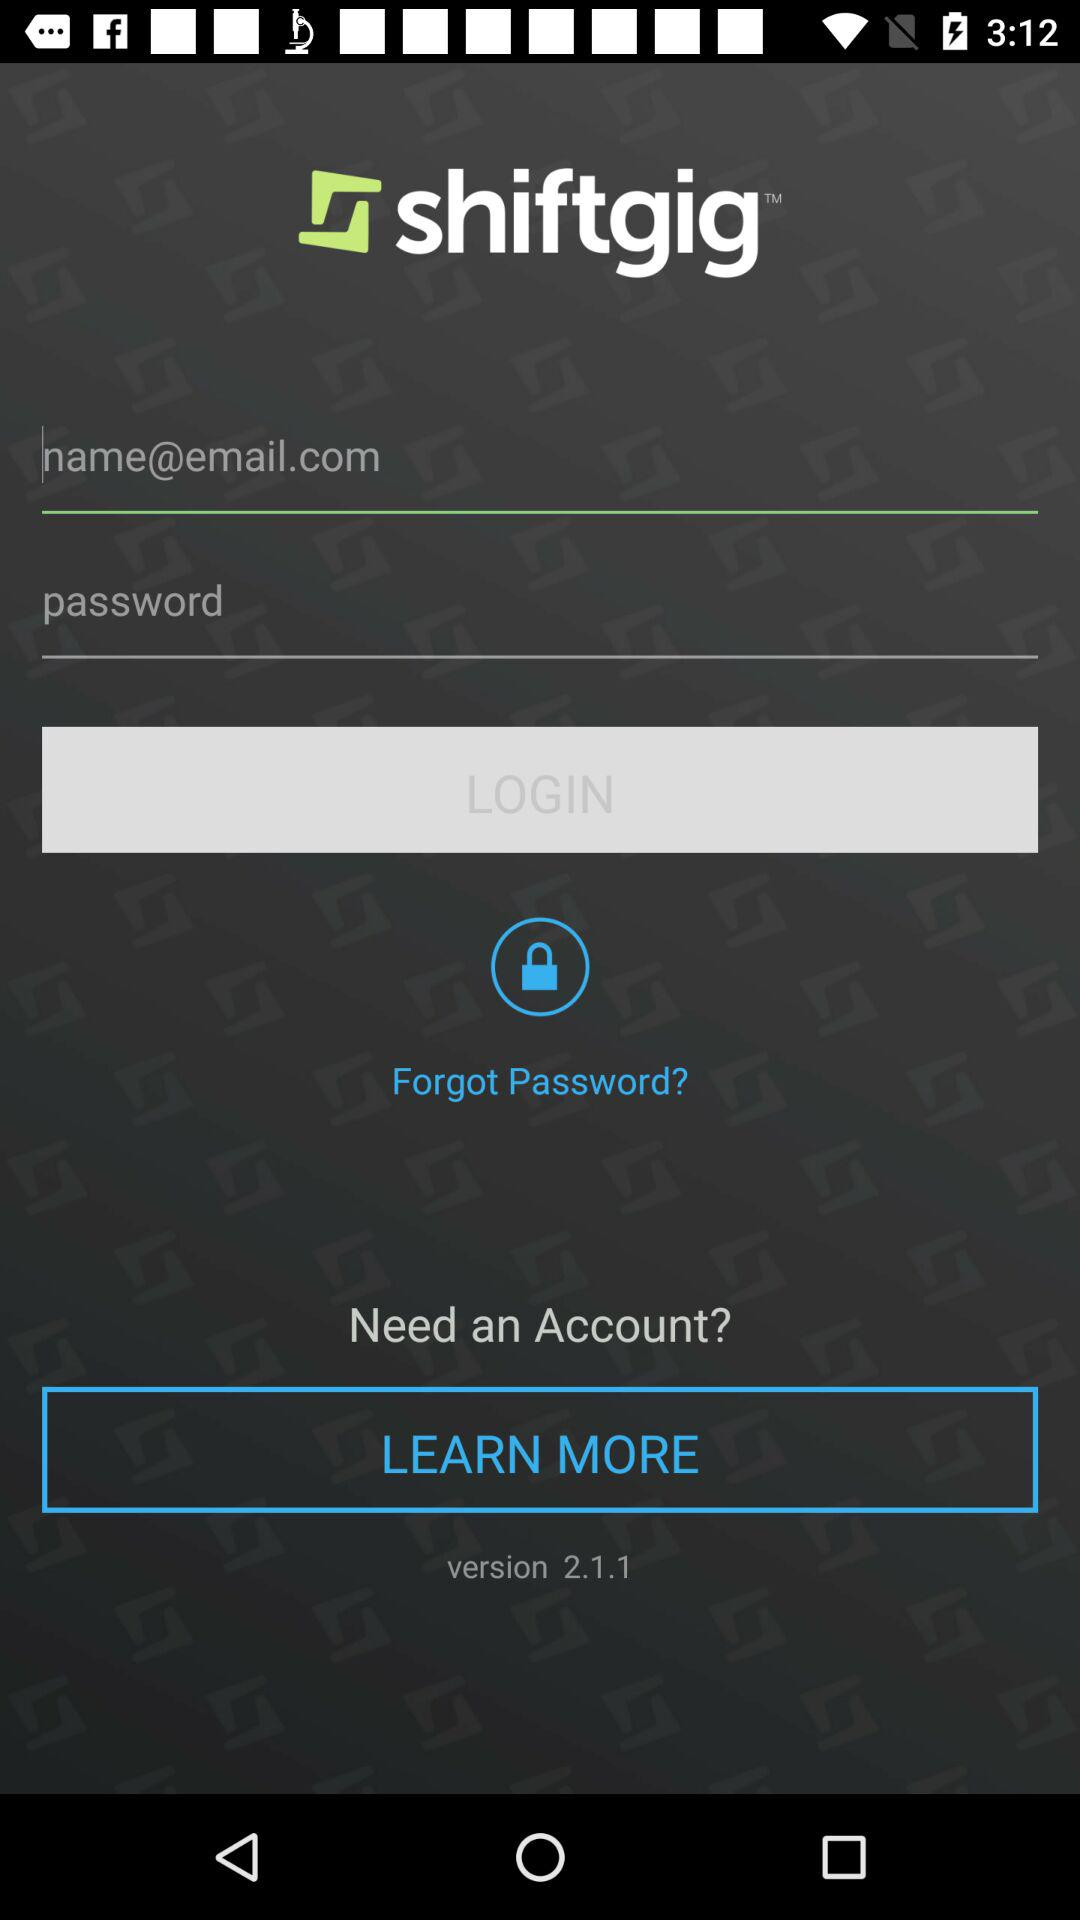What is the name of the application? The name of the application is "shiftgig". 